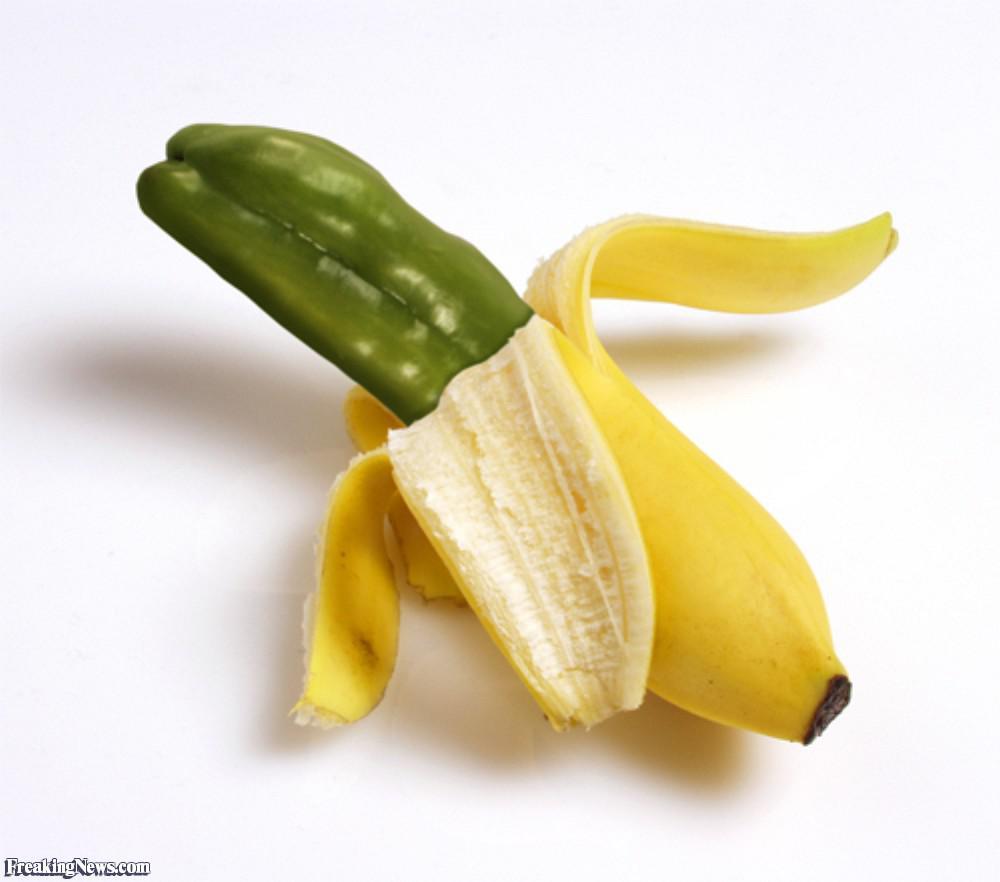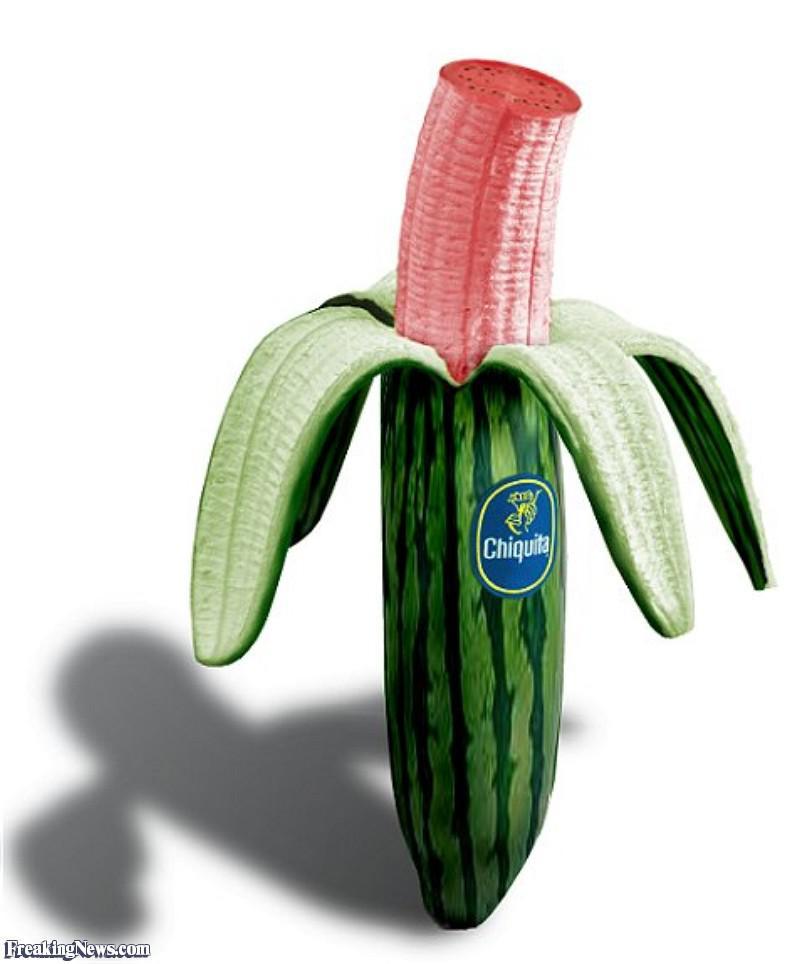The first image is the image on the left, the second image is the image on the right. For the images displayed, is the sentence "The combined images include a pink-fleshed banana and a banana peel that resembles a different type of fruit." factually correct? Answer yes or no. Yes. 